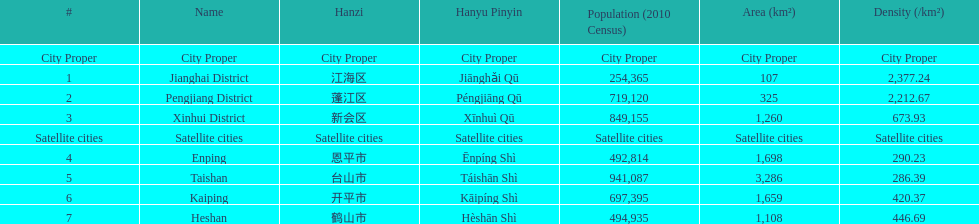Which of the satellite cities' areas has the largest population? Taishan. 